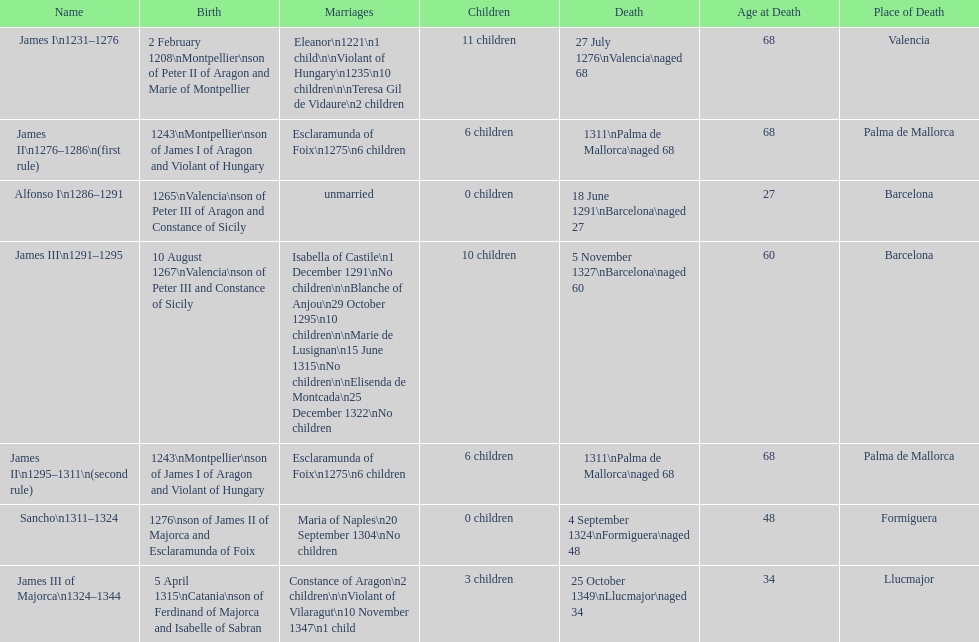Which monarch is listed first? James I 1231-1276. 